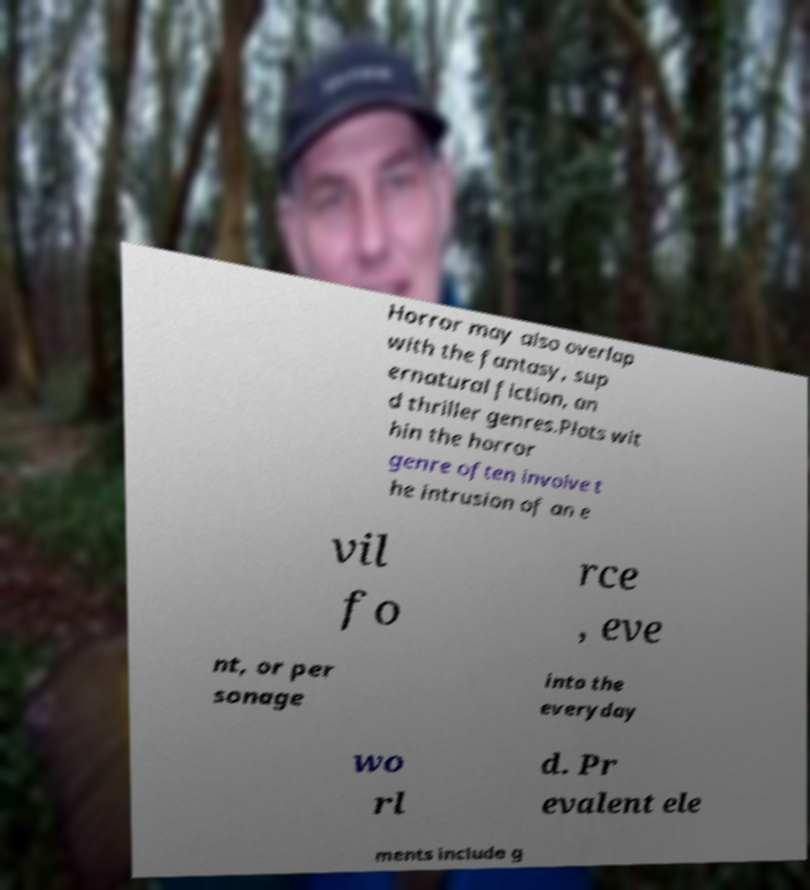Could you extract and type out the text from this image? Horror may also overlap with the fantasy, sup ernatural fiction, an d thriller genres.Plots wit hin the horror genre often involve t he intrusion of an e vil fo rce , eve nt, or per sonage into the everyday wo rl d. Pr evalent ele ments include g 